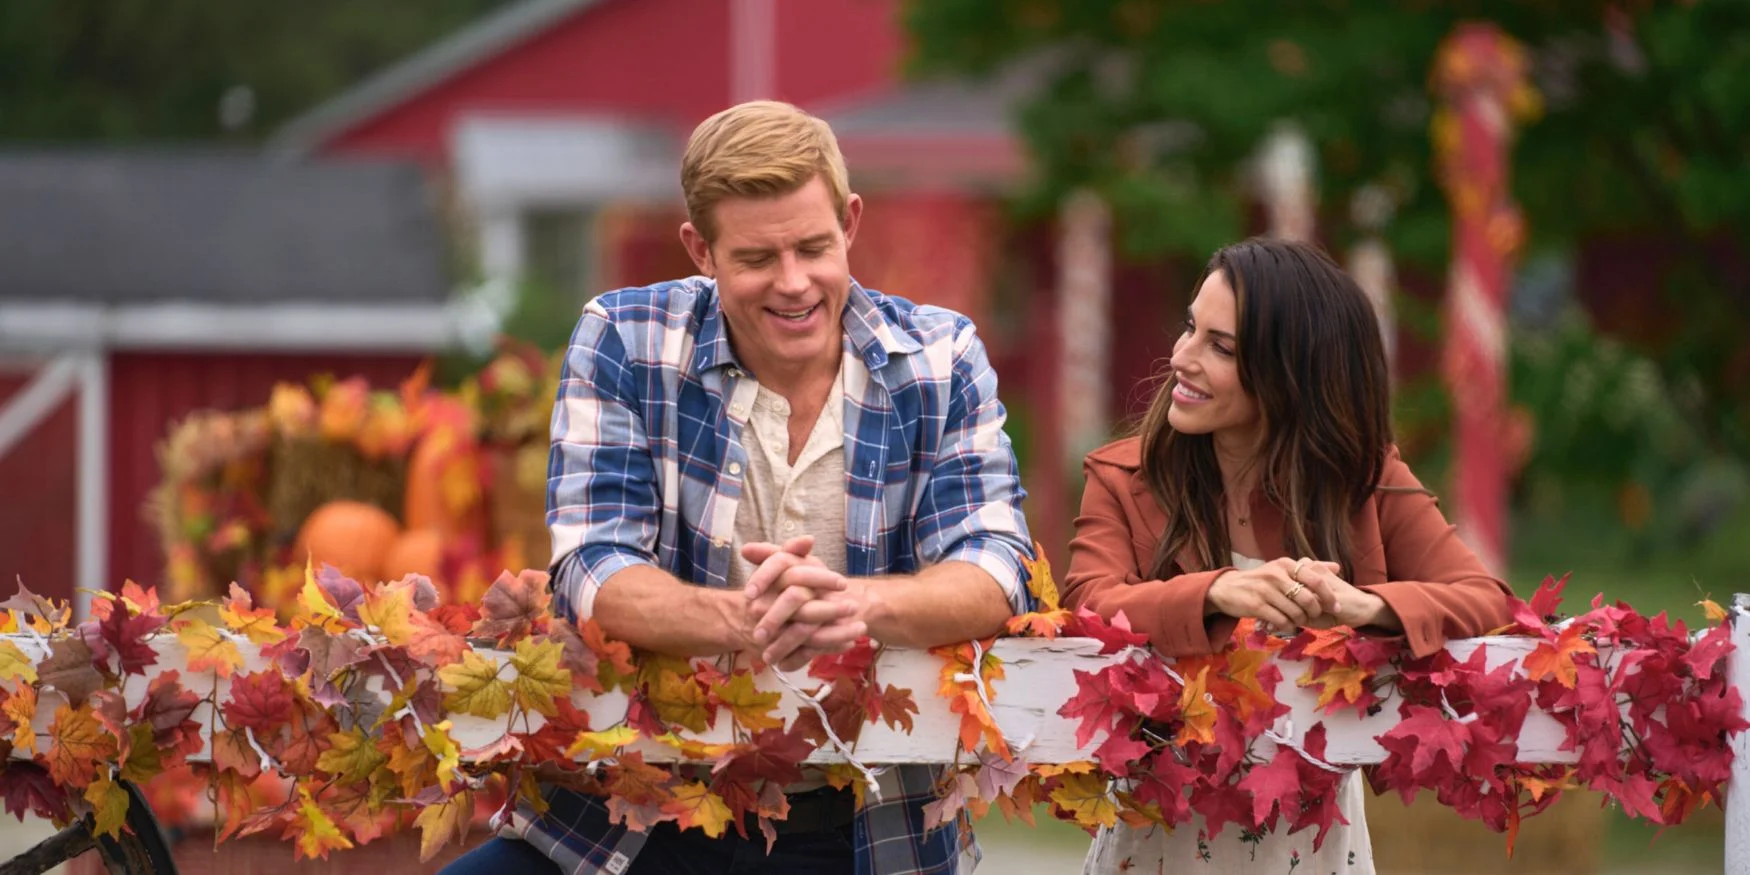Explain the visual content of the image in great detail. In this image, two individuals, Trevor Donovan and Jana Kramer, are situated in a picturesque, autumnal setting. Trevor Donovan, wearing a blue and white plaid shirt, leans casually against a white fence that is festooned with vibrant, colorful autumn leaves. Adjacent to him, Jana Kramer, dressed in a maroon top, adopts a similar relaxed posture. Both of them are engrossed in a conversation, illuminated by warm smiles. The background features a charming red barn and several pumpkins scattered around, heightening the fall ambiance. It's a scene brimming with seasonal warmth and the cozy camaraderie between the two actors. 